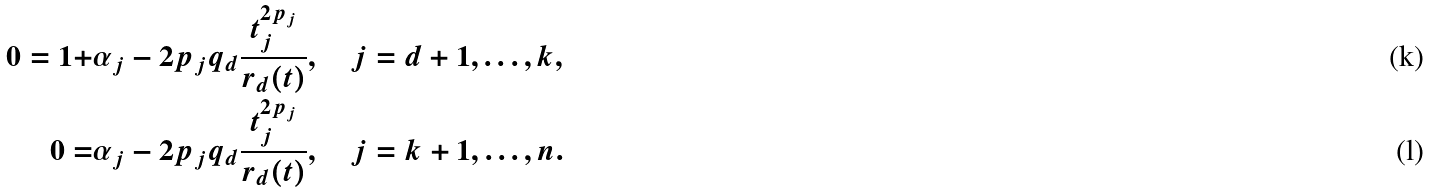<formula> <loc_0><loc_0><loc_500><loc_500>0 = 1 + & \alpha _ { j } - 2 p _ { j } q _ { d } \frac { t _ { j } ^ { 2 p _ { j } } } { r _ { d } ( t ) } , \quad j = d + 1 , \dots , k , \\ 0 = & \alpha _ { j } - 2 p _ { j } q _ { d } \frac { t _ { j } ^ { 2 p _ { j } } } { r _ { d } ( t ) } , \quad j = k + 1 , \dots , n .</formula> 